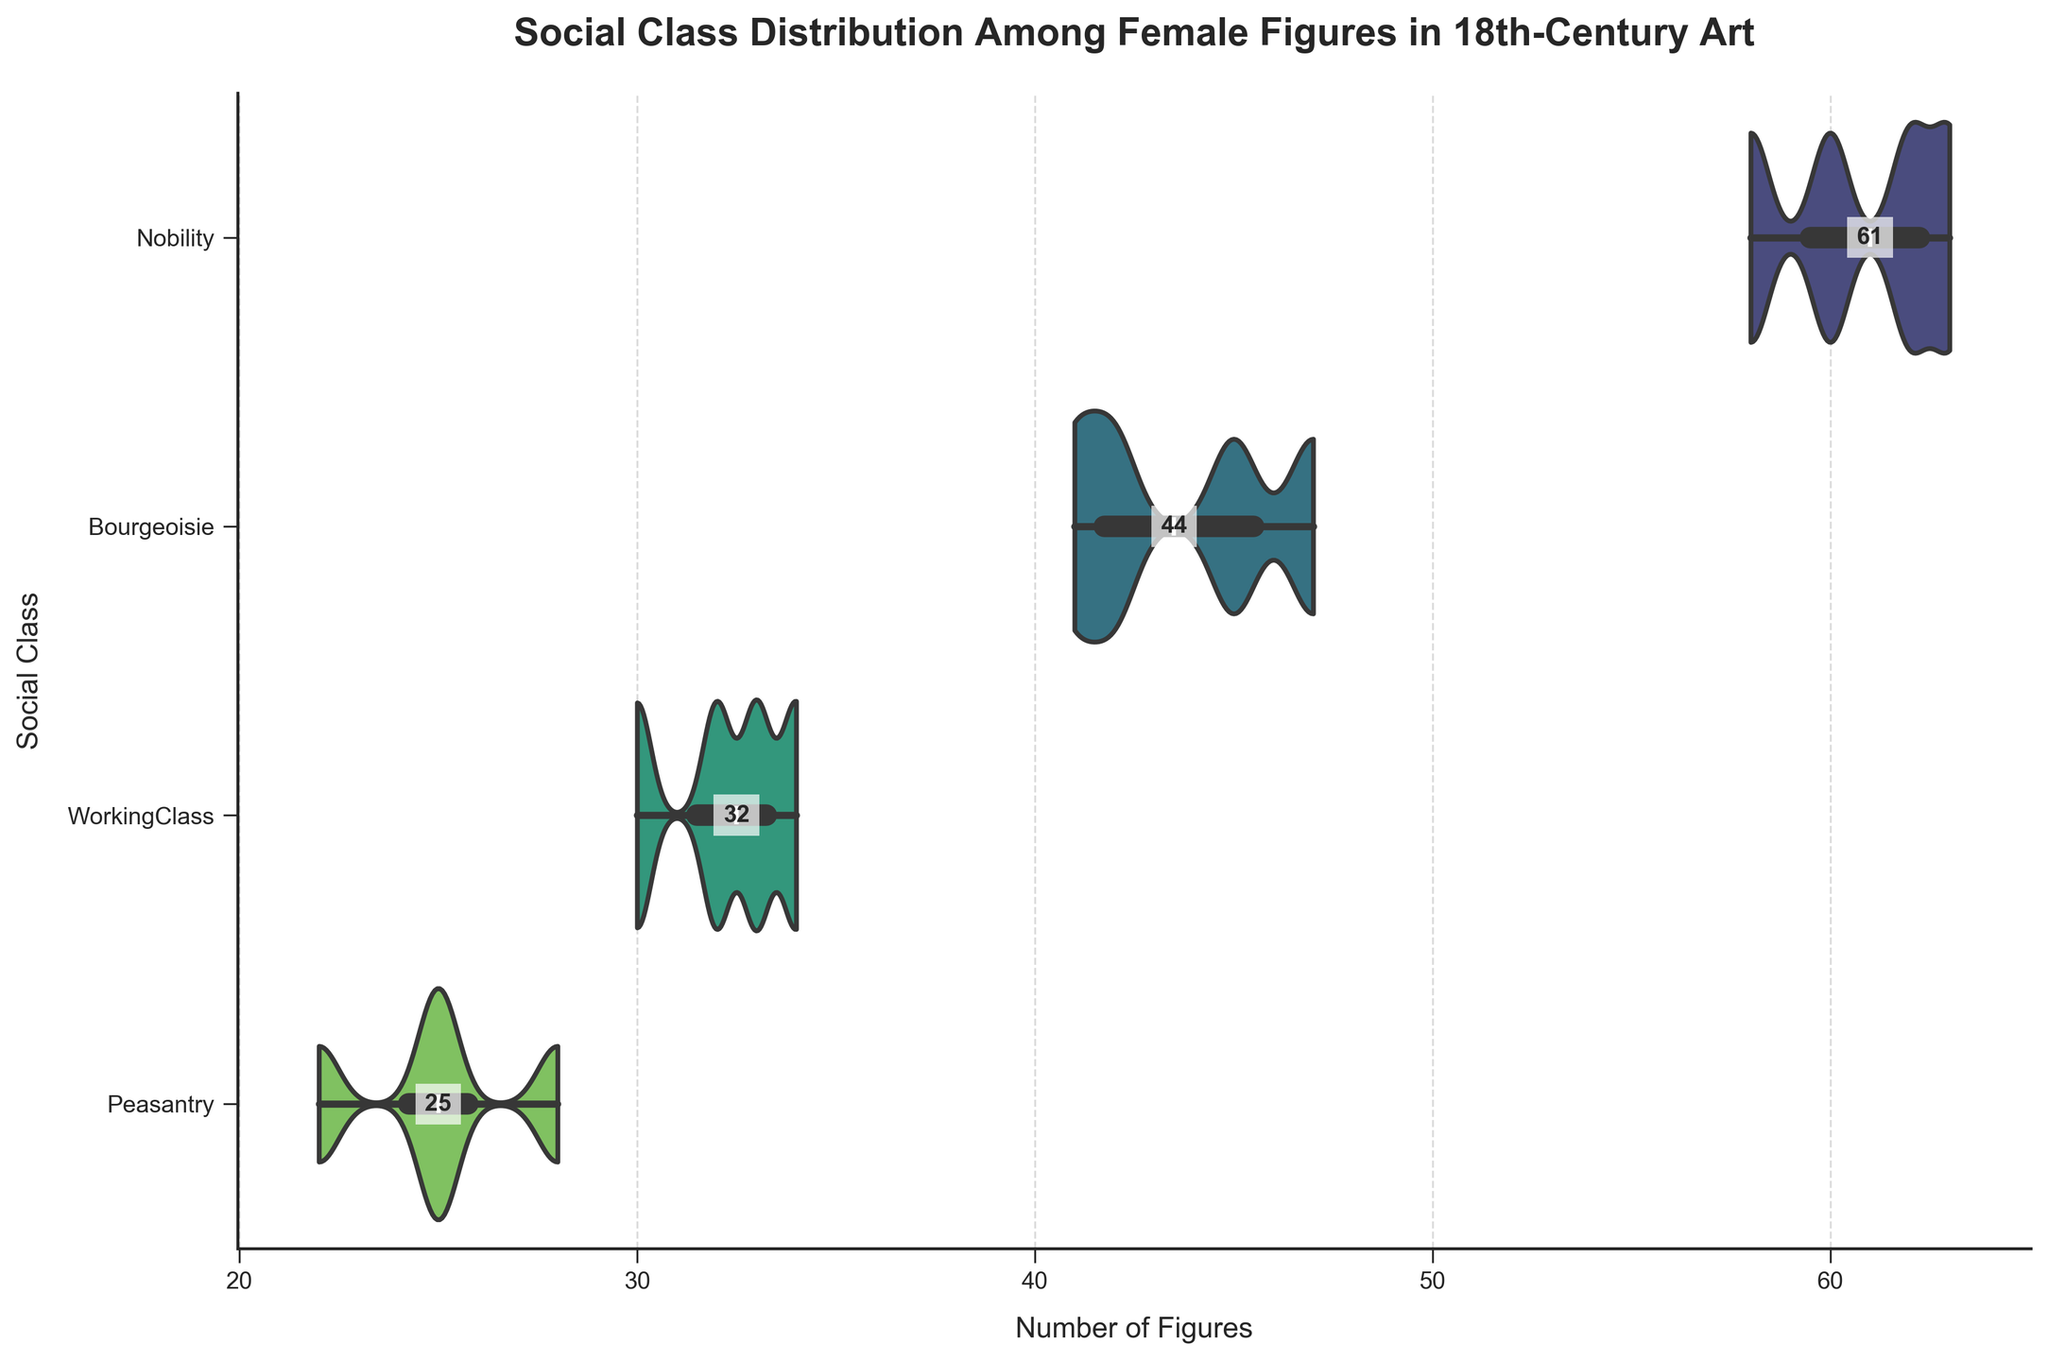What is the title of the figure? The title of the figure can be directly read from the top of the visualization. The title is "Social Class Distribution Among Female Figures in 18th-Century Art".
Answer: Social Class Distribution Among Female Figures in 18th-Century Art How many social classes are represented in the figure? The number of social classes is indicated on the y-axis of the figure, representing different social strata. Counting the unique labels on this axis will give the answer.
Answer: 4 Which social class has the widest range of figures? To determine the social class with the widest range of figures, observe the width of the violin plots. The plot that spans the greatest horizontal distance has the widest range.
Answer: Nobility What is the median number of figures for the peasantry class? To find the median number of figures for the peasantry class, look at the horizontal line within the peasantry violin plot, which represents the median value.
Answer: 25 Which social class has the fewest figures overall? To identify the social class with the fewest figures overall, observe the position and extent of the violin plots. Look at the social class plots that are most compressed or have the least horizontal spread.
Answer: Peasantry What is the approximate average number of figures for the bourgeoisie? The average number can be estimated using the violin plot density and the central tendency represented within the plot. The average would be around the central area of the Bourgeoisie plot.
Answer: 43.75 How does the number of figures in the working class compare to the number in the bourgeoisie? Comparing the median values and spans of the violin plots for the working class and bourgeoisie provides a measure of their central tendencies and range. The working class generally has fewer figures compared to the bourgeoisie.
Answer: Working class has fewer figures than the bourgeoisie What insight can be drawn about the social class distribution from the figure? The figure indicates that the nobility and bourgeoisie classes are more frequently represented among female figures in 18th-century art compared to the working class and peasantry. This can be inferred from the greater width and median values in the violin plots for these classes.
Answer: Nobility and bourgeoisie are more frequently depicted than working class and peasantry What is the interquartile range (IQR) of the number of figures for the nobility class? The interquartile range can be determined by finding the edges of the inner box within the nobility violin plot, which represents the 25th and 75th percentiles. Subtract the 25th percentile value from the 75th percentile value.
Answer: Approximately 5 (68 - 63) Create a detailed comparison of the representation of female figures in the bourgeoisie and working classes. First, note the median values for each class, which are shown by the horizontal lines in the violin plots. Then compare the spread or width of each plot, showing how figures vary around the medians (variability). The bourgeoisie has a higher median and a wider spread compared to the working class, indicating greater variability and representation among female figures depicted from this class in 18th-century art.
Answer: Bourgeoisie has a higher median and wider spread compared to the working class 